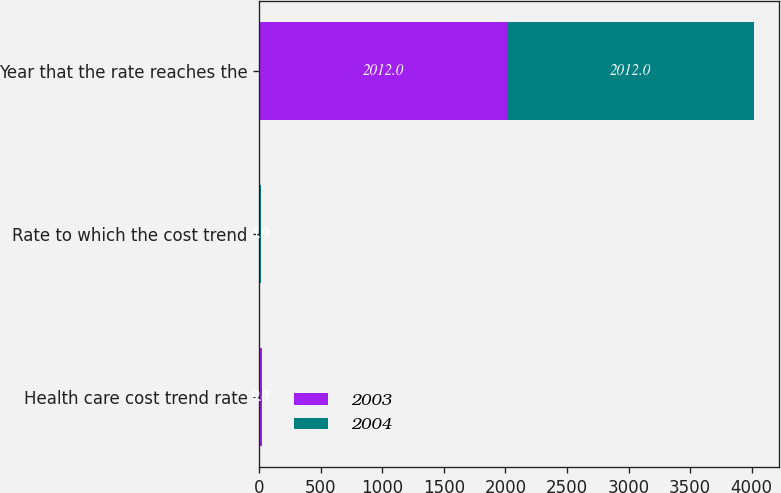Convert chart to OTSL. <chart><loc_0><loc_0><loc_500><loc_500><stacked_bar_chart><ecel><fcel>Health care cost trend rate<fcel>Rate to which the cost trend<fcel>Year that the rate reaches the<nl><fcel>2003<fcel>9<fcel>5<fcel>2012<nl><fcel>2004<fcel>9.5<fcel>5<fcel>2012<nl></chart> 